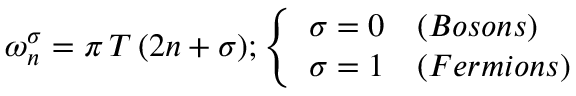<formula> <loc_0><loc_0><loc_500><loc_500>{ \omega _ { n } ^ { \sigma } = \pi \, T \, ( 2 n + \sigma ) } ; \left \{ \begin{array} { l l } { \sigma = 0 } & { ( B o s o n s ) } \\ { \sigma = 1 } & { ( F e r m i o n s ) } \end{array}</formula> 